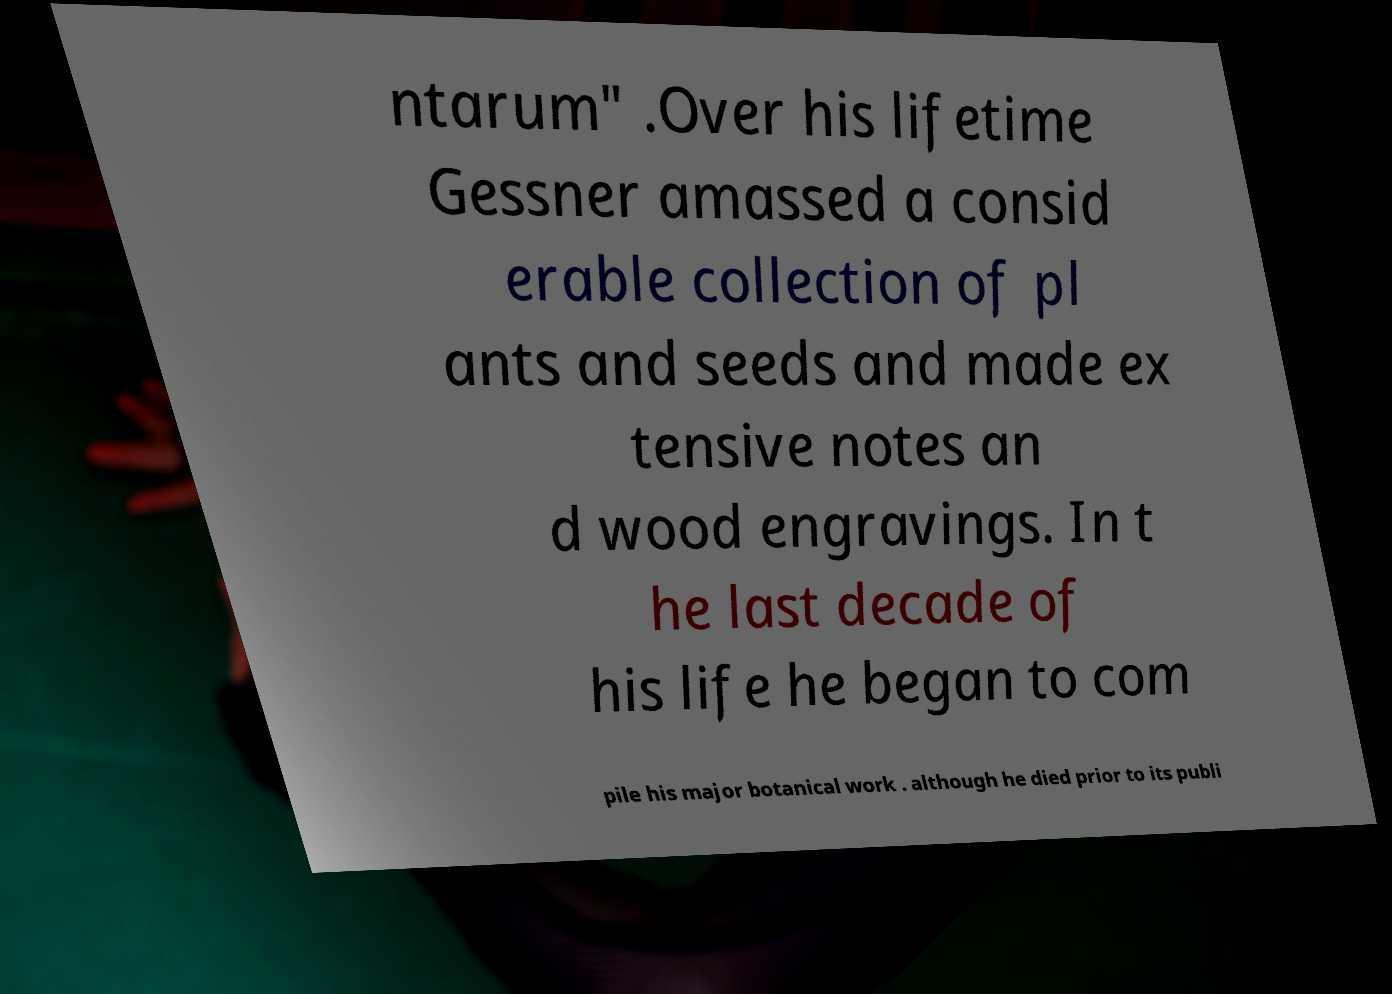I need the written content from this picture converted into text. Can you do that? ntarum" .Over his lifetime Gessner amassed a consid erable collection of pl ants and seeds and made ex tensive notes an d wood engravings. In t he last decade of his life he began to com pile his major botanical work . although he died prior to its publi 